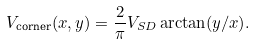<formula> <loc_0><loc_0><loc_500><loc_500>V _ { \text {corner} } ( x , y ) = \frac { 2 } { \pi } V _ { S D } \arctan ( y / x ) .</formula> 